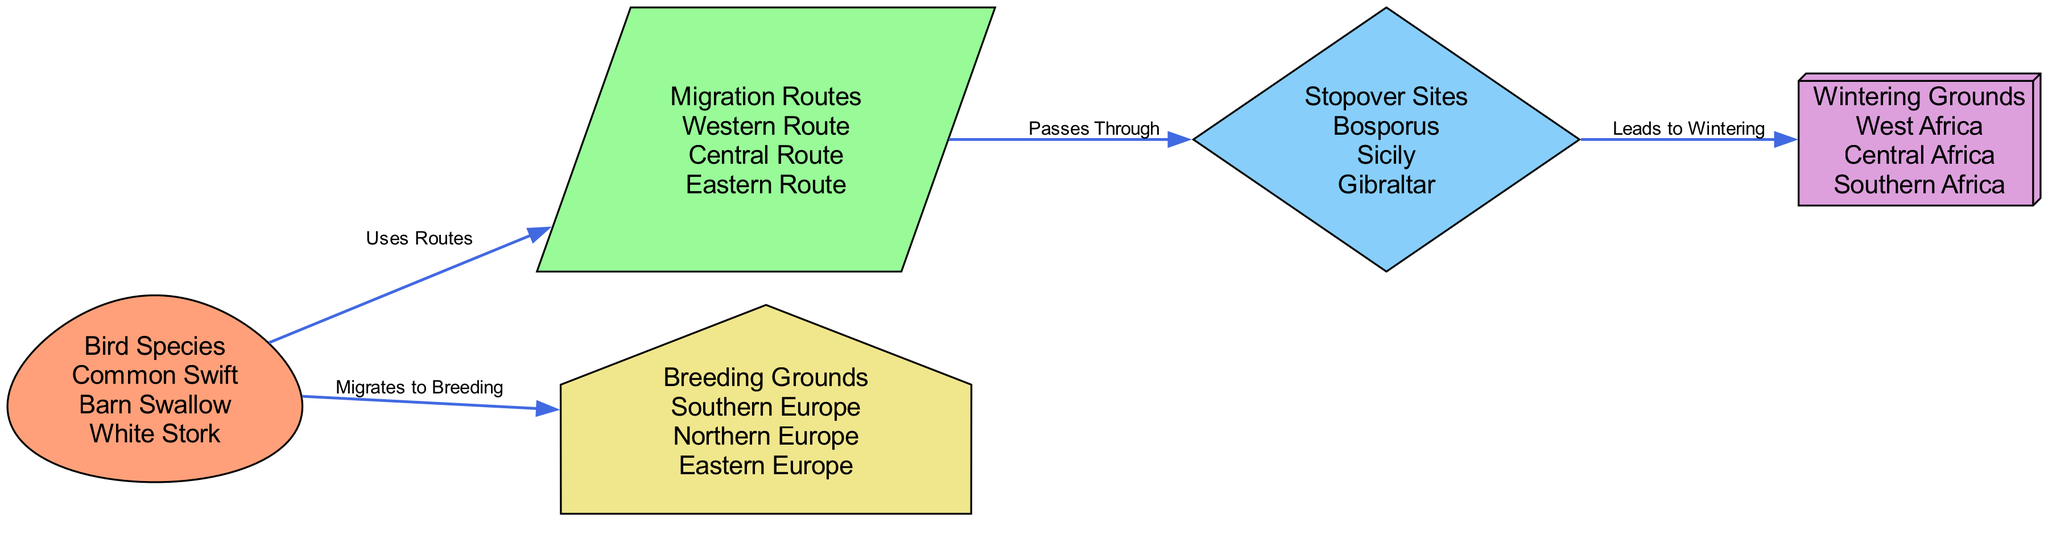What bird species utilizes the Western Route? The diagram shows that the "Common Swift," "Barn Swallow," and "White Stork" are all connected to the "Western Route." Therefore, the specific answer is "Common Swift," as it is one of the bird species utilizing this route.
Answer: Common Swift How many migration routes are displayed? By analyzing the diagram, there are three migration routes labeled: "Western Route," "Central Route," and "Eastern Route." Thus, counting them gives a total of three migration routes.
Answer: 3 Which stopover site is linked to wintering grounds in Southern Africa? The diagram indicates that the "Gibraltar" stopover site leads to wintering grounds. Specifically, the "Stopover Sites" node connects to the "Wintering Grounds" node, and one of the wintering grounds listed is "Southern Africa." Therefore, "Gibraltar" is the stopover site that connects to "Southern Africa."
Answer: Gibraltar What shape represents the Wintering Grounds? In the diagram, the "Wintering Grounds" node is represented as a "box3d." This is identified directly from the diagram's styling specifications that define nodes and their shapes.
Answer: box3d Which bird species migrates to breeding grounds in Northern Europe? The diagram shows that the bird species migrates to the breeding grounds. "Common Swift," "Barn Swallow," and "White Stork" are linked to "Breeding Grounds," which include "Northern Europe." Since the specific species isn't individually enumerated for that breeding ground, all three species could potentially migrate to it, but any one will suffice for an answer.
Answer: Common Swift What do stopover sites lead to? The diagram states that the "Stopover Sites" pass through to the "Wintering Grounds." Thus, the answer is clearly defined within the relationships of the nodes, indicating what they lead to.
Answer: Wintering Grounds Which route do the Barn Swallow, Common Swift, and White Stork all utilize? The diagram indicates that all three species are collectively linked to the "Migration Routes" node, where they specifically utilize the "Western Route," "Central Route," and "Eastern Route." Hence, it’s sufficient to denote that they utilize multiple routes.
Answer: Western Route, Central Route, Eastern Route 